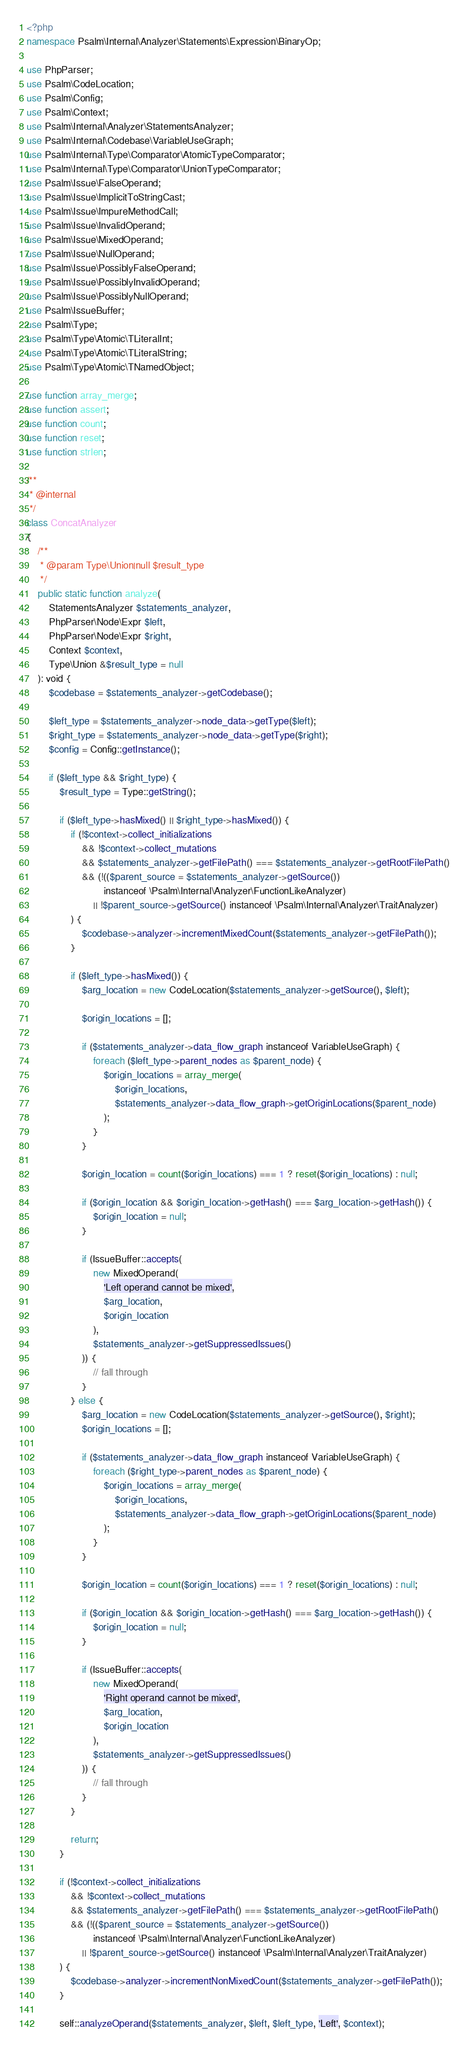<code> <loc_0><loc_0><loc_500><loc_500><_PHP_><?php
namespace Psalm\Internal\Analyzer\Statements\Expression\BinaryOp;

use PhpParser;
use Psalm\CodeLocation;
use Psalm\Config;
use Psalm\Context;
use Psalm\Internal\Analyzer\StatementsAnalyzer;
use Psalm\Internal\Codebase\VariableUseGraph;
use Psalm\Internal\Type\Comparator\AtomicTypeComparator;
use Psalm\Internal\Type\Comparator\UnionTypeComparator;
use Psalm\Issue\FalseOperand;
use Psalm\Issue\ImplicitToStringCast;
use Psalm\Issue\ImpureMethodCall;
use Psalm\Issue\InvalidOperand;
use Psalm\Issue\MixedOperand;
use Psalm\Issue\NullOperand;
use Psalm\Issue\PossiblyFalseOperand;
use Psalm\Issue\PossiblyInvalidOperand;
use Psalm\Issue\PossiblyNullOperand;
use Psalm\IssueBuffer;
use Psalm\Type;
use Psalm\Type\Atomic\TLiteralInt;
use Psalm\Type\Atomic\TLiteralString;
use Psalm\Type\Atomic\TNamedObject;

use function array_merge;
use function assert;
use function count;
use function reset;
use function strlen;

/**
 * @internal
 */
class ConcatAnalyzer
{
    /**
     * @param Type\Union|null $result_type
     */
    public static function analyze(
        StatementsAnalyzer $statements_analyzer,
        PhpParser\Node\Expr $left,
        PhpParser\Node\Expr $right,
        Context $context,
        Type\Union &$result_type = null
    ): void {
        $codebase = $statements_analyzer->getCodebase();

        $left_type = $statements_analyzer->node_data->getType($left);
        $right_type = $statements_analyzer->node_data->getType($right);
        $config = Config::getInstance();

        if ($left_type && $right_type) {
            $result_type = Type::getString();

            if ($left_type->hasMixed() || $right_type->hasMixed()) {
                if (!$context->collect_initializations
                    && !$context->collect_mutations
                    && $statements_analyzer->getFilePath() === $statements_analyzer->getRootFilePath()
                    && (!(($parent_source = $statements_analyzer->getSource())
                            instanceof \Psalm\Internal\Analyzer\FunctionLikeAnalyzer)
                        || !$parent_source->getSource() instanceof \Psalm\Internal\Analyzer\TraitAnalyzer)
                ) {
                    $codebase->analyzer->incrementMixedCount($statements_analyzer->getFilePath());
                }

                if ($left_type->hasMixed()) {
                    $arg_location = new CodeLocation($statements_analyzer->getSource(), $left);

                    $origin_locations = [];

                    if ($statements_analyzer->data_flow_graph instanceof VariableUseGraph) {
                        foreach ($left_type->parent_nodes as $parent_node) {
                            $origin_locations = array_merge(
                                $origin_locations,
                                $statements_analyzer->data_flow_graph->getOriginLocations($parent_node)
                            );
                        }
                    }

                    $origin_location = count($origin_locations) === 1 ? reset($origin_locations) : null;

                    if ($origin_location && $origin_location->getHash() === $arg_location->getHash()) {
                        $origin_location = null;
                    }

                    if (IssueBuffer::accepts(
                        new MixedOperand(
                            'Left operand cannot be mixed',
                            $arg_location,
                            $origin_location
                        ),
                        $statements_analyzer->getSuppressedIssues()
                    )) {
                        // fall through
                    }
                } else {
                    $arg_location = new CodeLocation($statements_analyzer->getSource(), $right);
                    $origin_locations = [];

                    if ($statements_analyzer->data_flow_graph instanceof VariableUseGraph) {
                        foreach ($right_type->parent_nodes as $parent_node) {
                            $origin_locations = array_merge(
                                $origin_locations,
                                $statements_analyzer->data_flow_graph->getOriginLocations($parent_node)
                            );
                        }
                    }

                    $origin_location = count($origin_locations) === 1 ? reset($origin_locations) : null;

                    if ($origin_location && $origin_location->getHash() === $arg_location->getHash()) {
                        $origin_location = null;
                    }

                    if (IssueBuffer::accepts(
                        new MixedOperand(
                            'Right operand cannot be mixed',
                            $arg_location,
                            $origin_location
                        ),
                        $statements_analyzer->getSuppressedIssues()
                    )) {
                        // fall through
                    }
                }

                return;
            }

            if (!$context->collect_initializations
                && !$context->collect_mutations
                && $statements_analyzer->getFilePath() === $statements_analyzer->getRootFilePath()
                && (!(($parent_source = $statements_analyzer->getSource())
                        instanceof \Psalm\Internal\Analyzer\FunctionLikeAnalyzer)
                    || !$parent_source->getSource() instanceof \Psalm\Internal\Analyzer\TraitAnalyzer)
            ) {
                $codebase->analyzer->incrementNonMixedCount($statements_analyzer->getFilePath());
            }

            self::analyzeOperand($statements_analyzer, $left, $left_type, 'Left', $context);</code> 